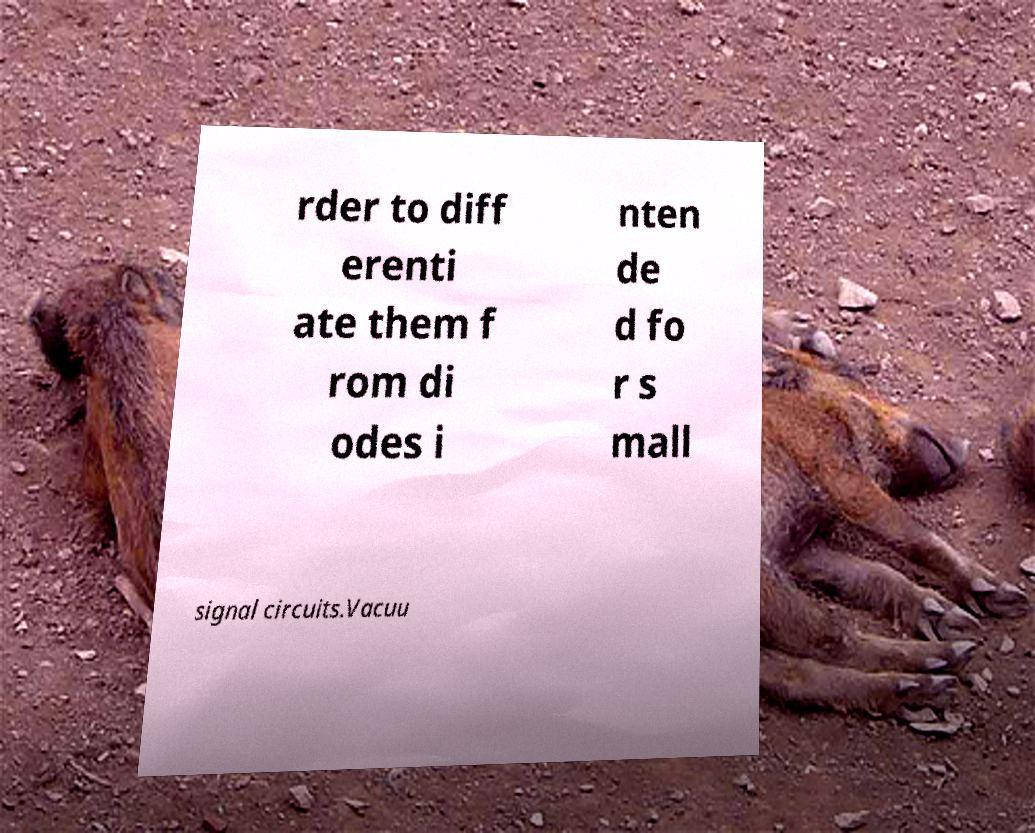Could you assist in decoding the text presented in this image and type it out clearly? rder to diff erenti ate them f rom di odes i nten de d fo r s mall signal circuits.Vacuu 